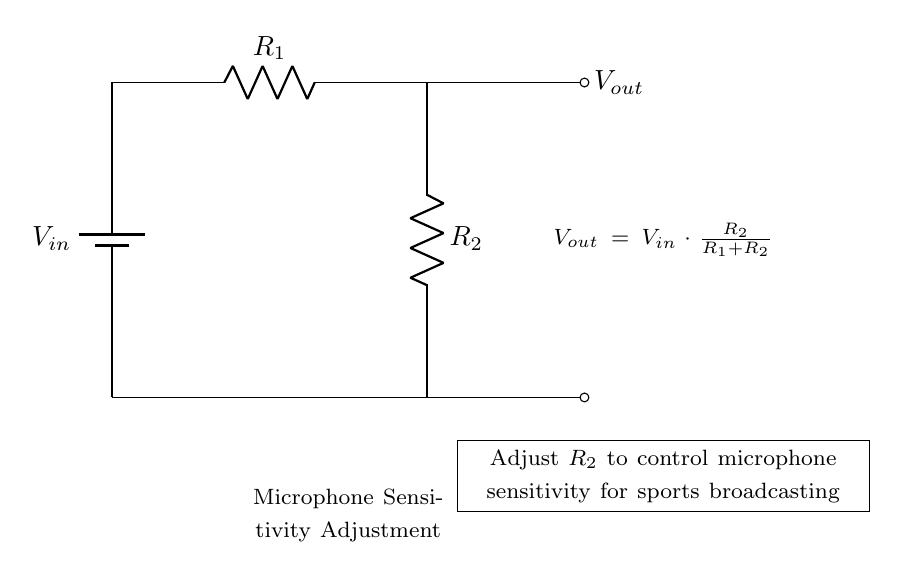What is the input voltage in this circuit? The input voltage is represented by \( V_{in} \) in the circuit diagram, which is typically provided by a battery or power supply.
Answer: \( V_{in} \) What component is used to adjust microphone sensitivity? The component used to adjust microphone sensitivity is \( R_2 \), which is part of the voltage divider and controls the output voltage based on its resistance value.
Answer: \( R_2 \) What is the formula for the output voltage in this voltage divider? The output voltage formula is shown in the diagram as \( V_{out} = V_{in} \cdot \frac{R_2}{R_1 + R_2} \). It represents how the output voltage depends on the input voltage and the resistance values.
Answer: \( V_{out} = V_{in} \cdot \frac{R_2}{R_1 + R_2} \) If \( R_1 \) is fixed and \( R_2 \) is increased, what happens to \( V_{out} \)? Increasing \( R_2 \) while \( R_1 \) is fixed increases the ratio \( \frac{R_2}{R_1 + R_2} \), resulting in a higher \( V_{out} \). This indicates that the output voltage increases with higher \( R_2 \).
Answer: Increases What type of circuit is this? This is a voltage divider circuit, specifically designed to reduce the voltage from the input to a lower voltage level suitable for the microphone sensitivity adjustment.
Answer: Voltage divider What do the nodes in the circuit represent? The nodes in the circuit represent junctions where components are connected. In this diagram, they indicate where the battery, resistors, and output voltage measurement points connect.
Answer: Junctions What would happen if \( R_2 \) were to be removed? Removing \( R_2 \) would result in no voltage division occurring, causing \( V_{out} \) to equal \( V_{in} \) directly, potentially making the microphone too sensitive or unusable.
Answer: \( V_{in} \) 